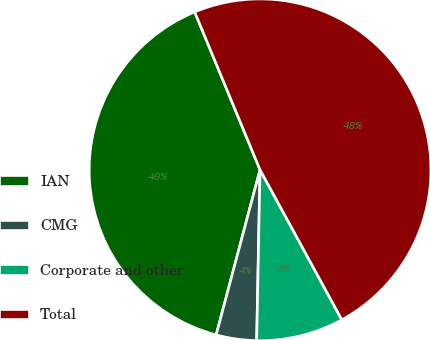Convert chart to OTSL. <chart><loc_0><loc_0><loc_500><loc_500><pie_chart><fcel>IAN<fcel>CMG<fcel>Corporate and other<fcel>Total<nl><fcel>39.62%<fcel>3.82%<fcel>8.26%<fcel>48.3%<nl></chart> 